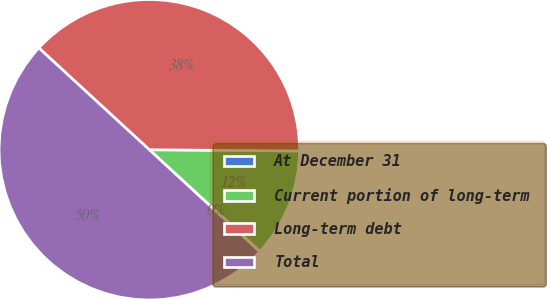<chart> <loc_0><loc_0><loc_500><loc_500><pie_chart><fcel>At December 31<fcel>Current portion of long-term<fcel>Long-term debt<fcel>Total<nl><fcel>0.05%<fcel>11.69%<fcel>38.28%<fcel>49.98%<nl></chart> 